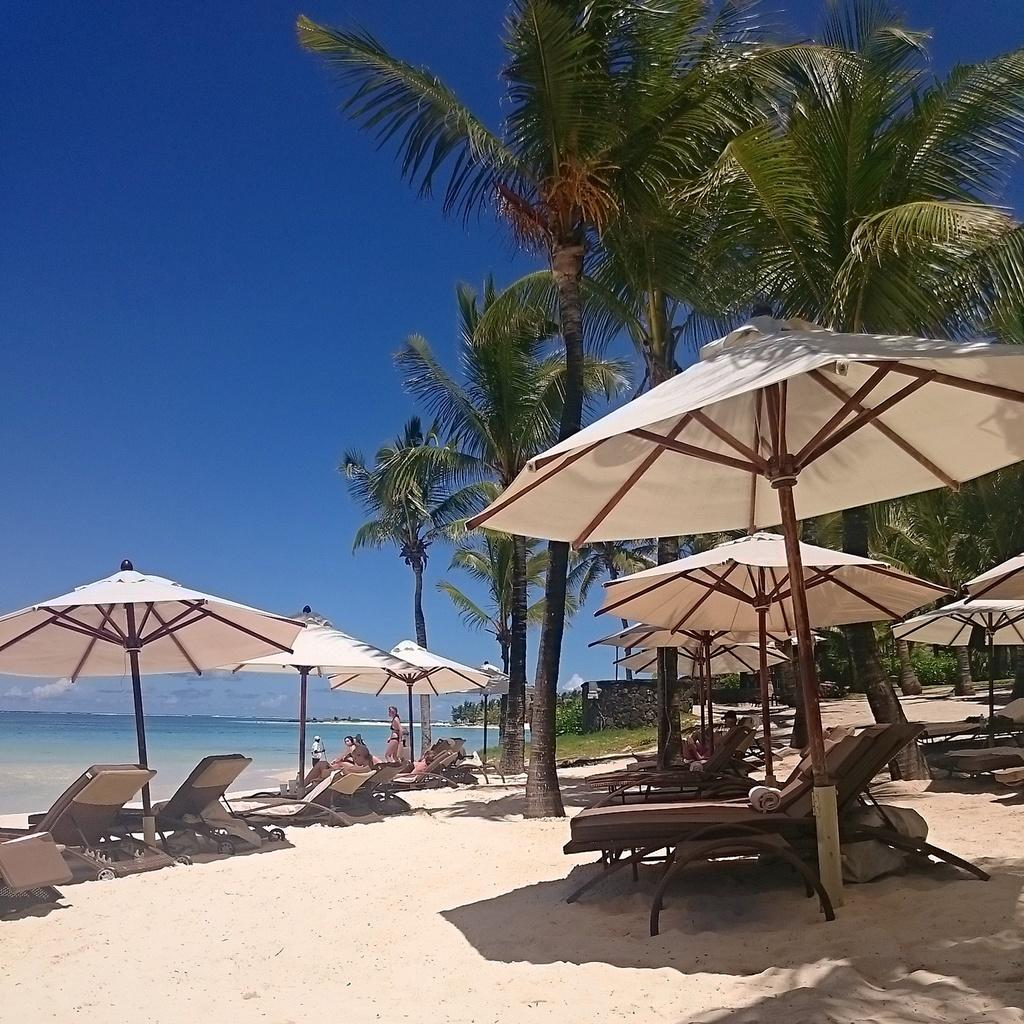What type of vegetation can be seen in the image? There are trees and grass in the image. What type of structure is present in the image? There is a wall in the image. What are the people in the image doing? There are people standing and sitting on benches in the image. What objects are present to provide shade in the image? There are umbrellas in the image. What can be seen in the background of the image? Water and the sky are visible in the image. What time of day is it in the image, and what position is the sun in the sky? The time of day and the position of the sun are not mentioned in the image. Can you tell me how many people are pushing the trees in the image? There is no indication that anyone is pushing the trees in the image; they are standing still. 